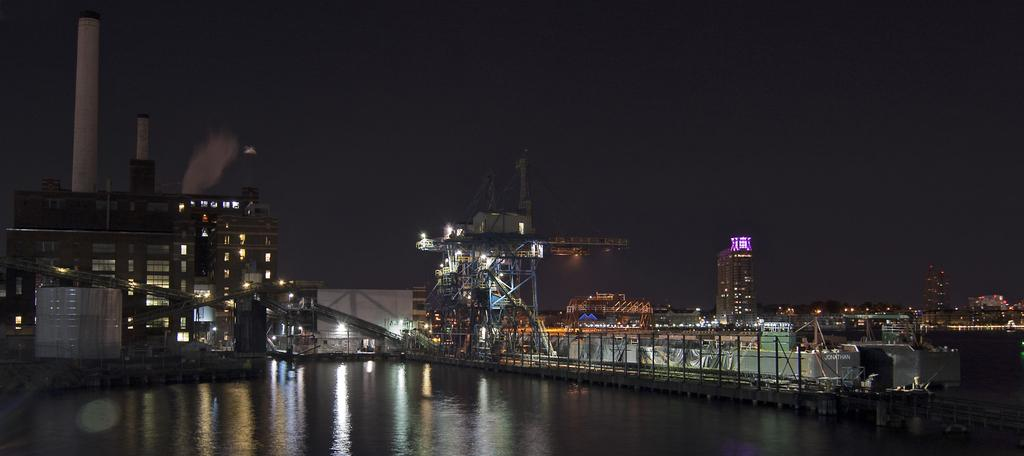What type of structures can be seen in the image? There are buildings in the image. What else is visible in the image besides the buildings? There are lights, water, a fence, and the sky visible in the image. Can you describe the water in the image? The water is visible in the image, but its specific characteristics are not mentioned in the facts. What is visible at the top of the image? The sky is visible at the top of the image. What is the reason for the railway tracks in the image? There are no railway tracks present in the image, so there is no reason for them. 